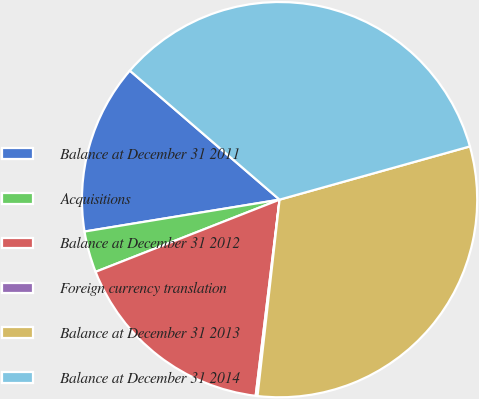<chart> <loc_0><loc_0><loc_500><loc_500><pie_chart><fcel>Balance at December 31 2011<fcel>Acquisitions<fcel>Balance at December 31 2012<fcel>Foreign currency translation<fcel>Balance at December 31 2013<fcel>Balance at December 31 2014<nl><fcel>13.9%<fcel>3.37%<fcel>17.12%<fcel>0.15%<fcel>31.12%<fcel>34.34%<nl></chart> 